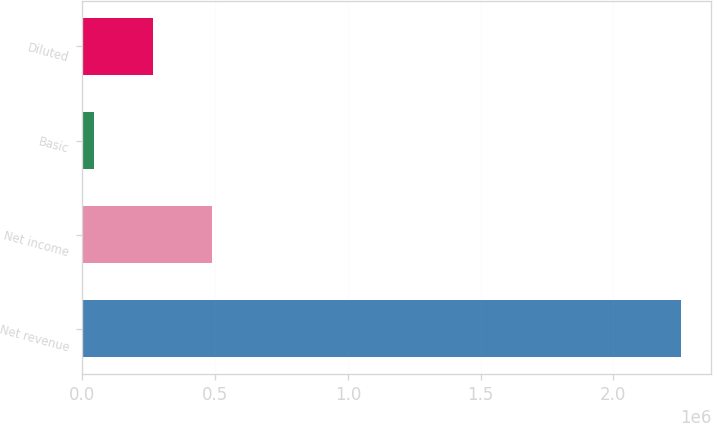Convert chart to OTSL. <chart><loc_0><loc_0><loc_500><loc_500><bar_chart><fcel>Net revenue<fcel>Net income<fcel>Basic<fcel>Diluted<nl><fcel>2.2557e+06<fcel>487142<fcel>45004<fcel>266073<nl></chart> 